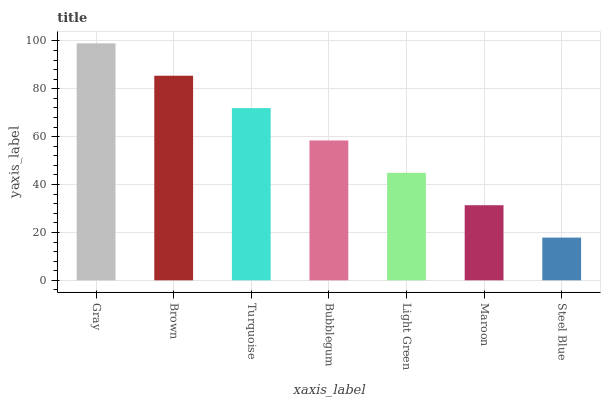Is Steel Blue the minimum?
Answer yes or no. Yes. Is Gray the maximum?
Answer yes or no. Yes. Is Brown the minimum?
Answer yes or no. No. Is Brown the maximum?
Answer yes or no. No. Is Gray greater than Brown?
Answer yes or no. Yes. Is Brown less than Gray?
Answer yes or no. Yes. Is Brown greater than Gray?
Answer yes or no. No. Is Gray less than Brown?
Answer yes or no. No. Is Bubblegum the high median?
Answer yes or no. Yes. Is Bubblegum the low median?
Answer yes or no. Yes. Is Light Green the high median?
Answer yes or no. No. Is Turquoise the low median?
Answer yes or no. No. 